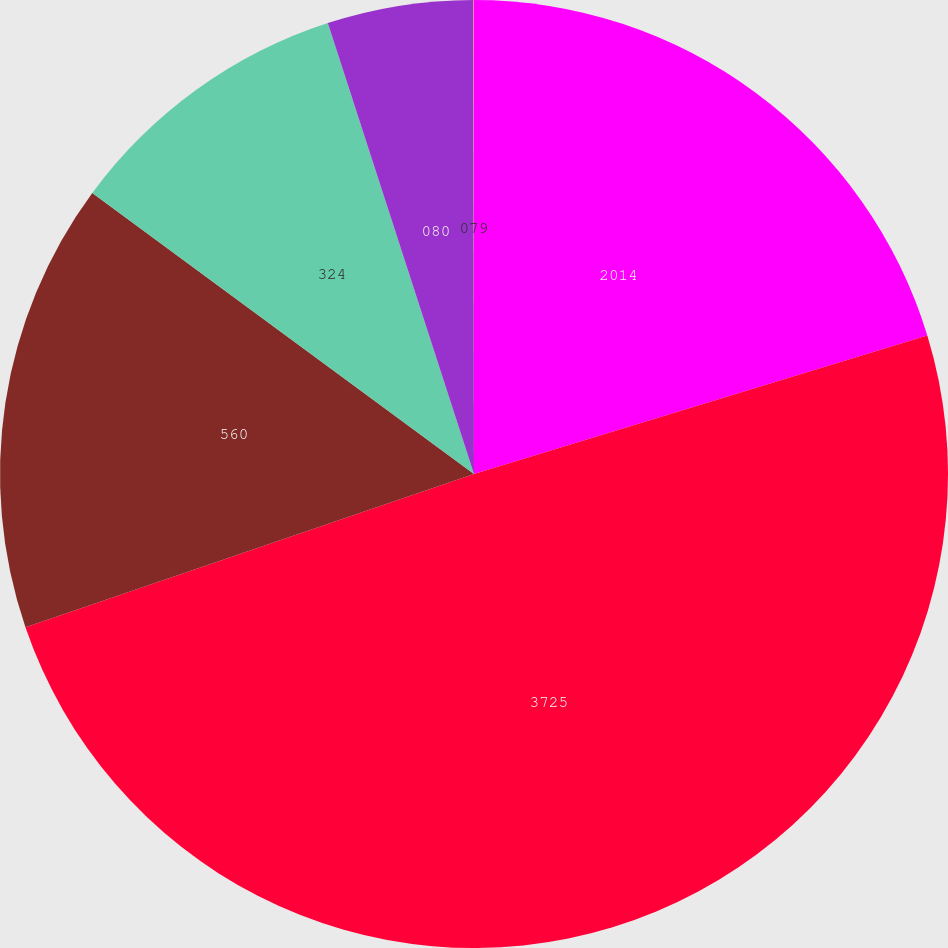<chart> <loc_0><loc_0><loc_500><loc_500><pie_chart><fcel>2014<fcel>3725<fcel>560<fcel>324<fcel>080<fcel>079<nl><fcel>20.28%<fcel>49.48%<fcel>15.34%<fcel>9.91%<fcel>4.97%<fcel>0.02%<nl></chart> 